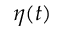Convert formula to latex. <formula><loc_0><loc_0><loc_500><loc_500>\eta ( t )</formula> 